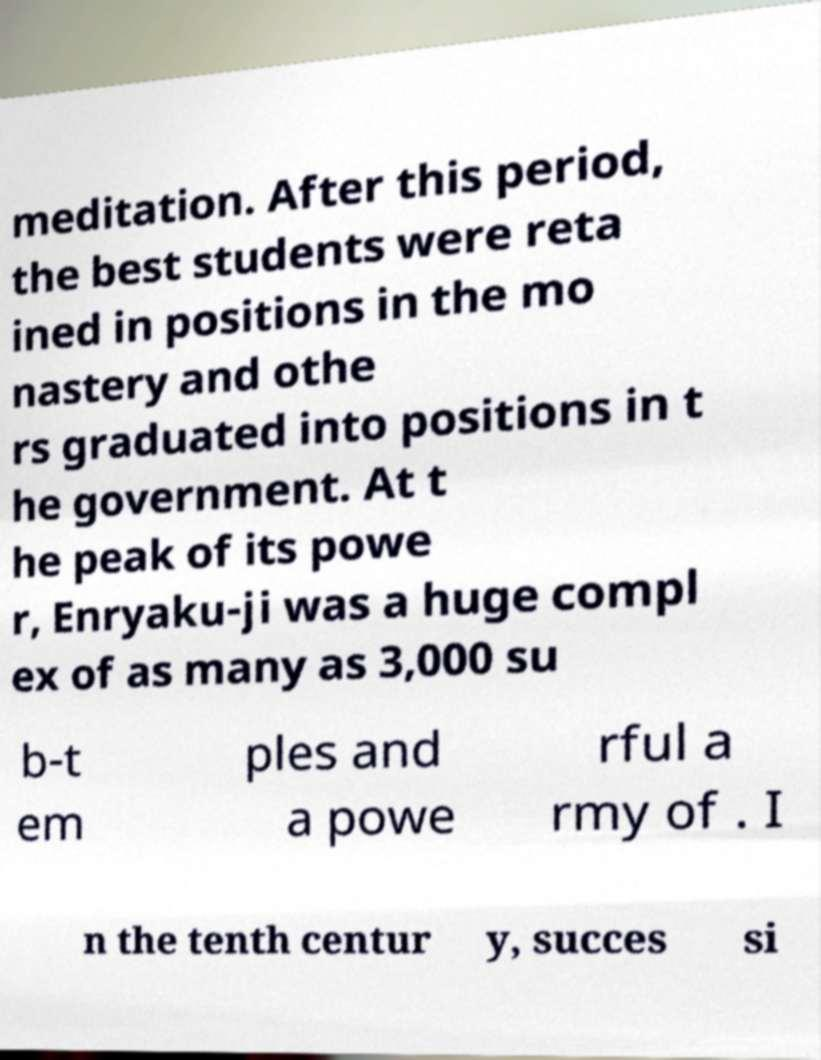Could you assist in decoding the text presented in this image and type it out clearly? meditation. After this period, the best students were reta ined in positions in the mo nastery and othe rs graduated into positions in t he government. At t he peak of its powe r, Enryaku-ji was a huge compl ex of as many as 3,000 su b-t em ples and a powe rful a rmy of . I n the tenth centur y, succes si 